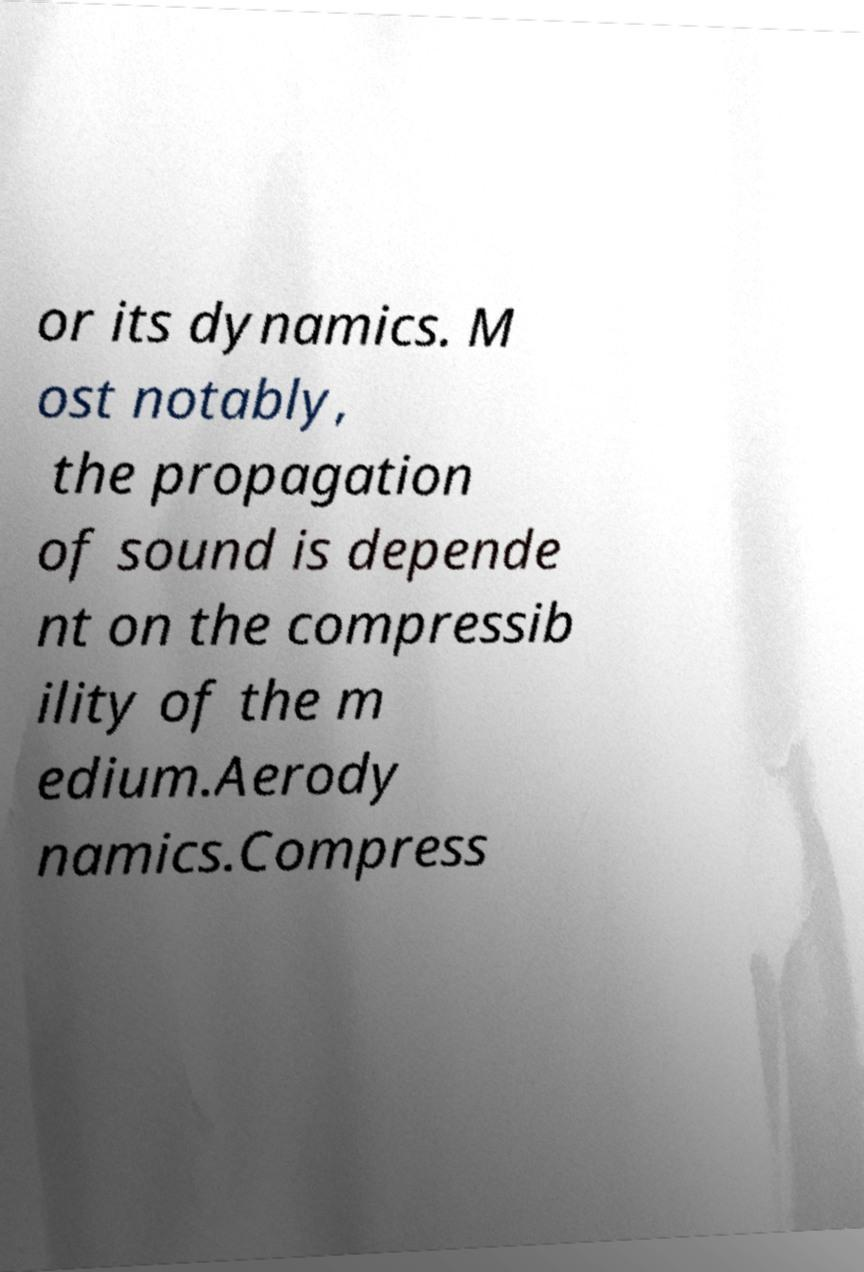For documentation purposes, I need the text within this image transcribed. Could you provide that? or its dynamics. M ost notably, the propagation of sound is depende nt on the compressib ility of the m edium.Aerody namics.Compress 